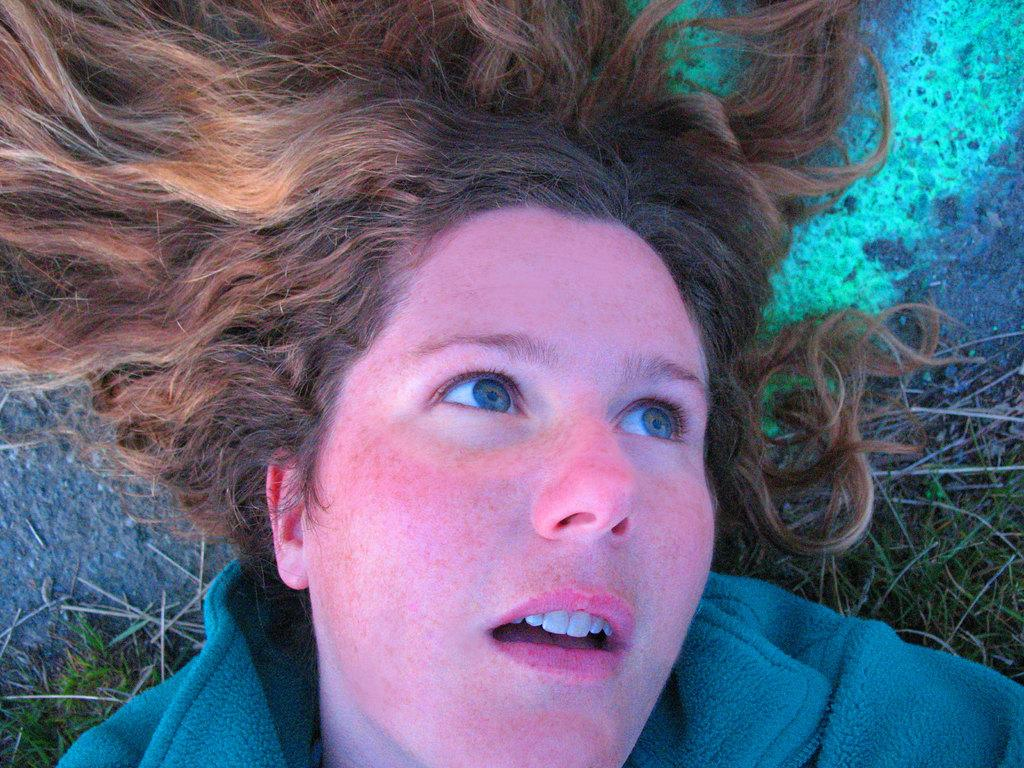Where was the image taken? The image was taken outdoors. What is the woman in the image doing? The woman is lying on the ground at the bottom of the image. What type of vegetation can be seen in the background of the image? There is grass on the ground in the background of the image. How many clocks are hanging from the tree in the image? There are no clocks present in the image, and no tree is visible. 